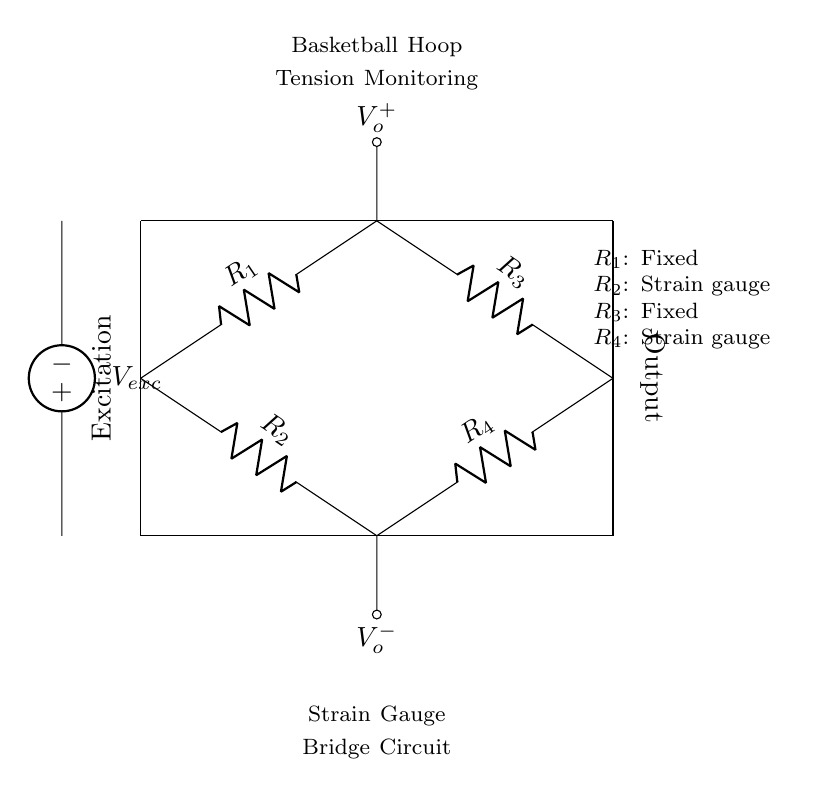What enables output voltage in this circuit? The output voltage is generated due to the difference in resistance caused by changes in strain on the strain gauges, which alters the voltage across the output terminals.
Answer: difference in resistance What components form the strain gauge bridge? The strain gauge bridge consists of two fixed resistors and two strain gauge resistors, specifically labeled as R1, R2, R3, and R4 in the circuit.
Answer: R1, R2, R3, R4 How many resistors are present in the circuit? There are four resistors in this circuit, which include two fixed resistors and two strain gauges.
Answer: four What is the purpose of voltage excitation in this circuit? Voltage excitation is applied to the bridge circuit to create a potential difference, which allows for the measurement of strain by the gauges and thereby the monitoring of tension in the basketball hoop.
Answer: create potential difference What type of circuit is represented by this diagram? The circuit diagram represents a strain gauge bridge circuit, specifically used for monitoring tension or strain.
Answer: strain gauge bridge circuit What happens at the output terminals of the circuit? The output terminals generate a voltage signal proportional to the tension or strain experienced by the basketball hoop based on the changes in resistance of the strain gauges.
Answer: voltage signal 